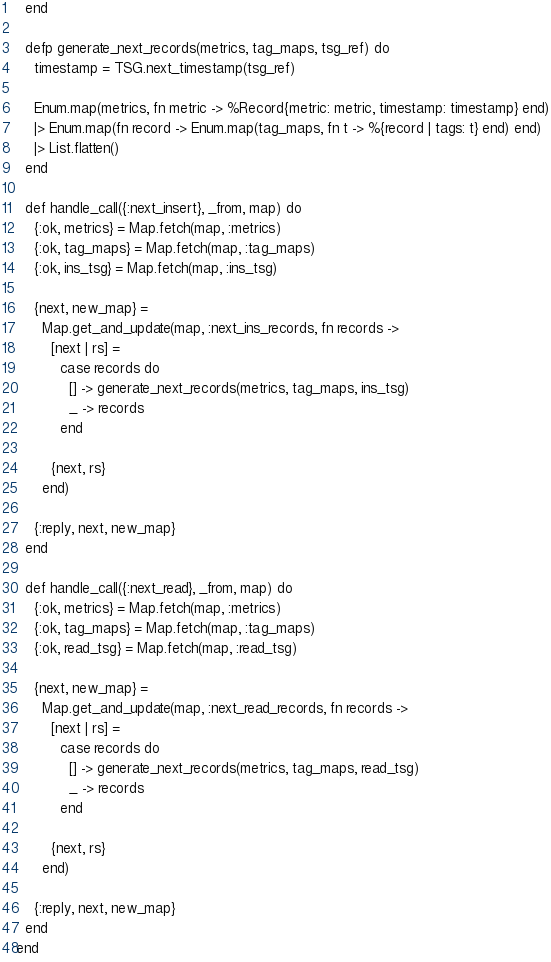<code> <loc_0><loc_0><loc_500><loc_500><_Elixir_>  end

  defp generate_next_records(metrics, tag_maps, tsg_ref) do
    timestamp = TSG.next_timestamp(tsg_ref)

    Enum.map(metrics, fn metric -> %Record{metric: metric, timestamp: timestamp} end)
    |> Enum.map(fn record -> Enum.map(tag_maps, fn t -> %{record | tags: t} end) end)
    |> List.flatten()
  end

  def handle_call({:next_insert}, _from, map) do
    {:ok, metrics} = Map.fetch(map, :metrics)
    {:ok, tag_maps} = Map.fetch(map, :tag_maps)
    {:ok, ins_tsg} = Map.fetch(map, :ins_tsg)

    {next, new_map} =
      Map.get_and_update(map, :next_ins_records, fn records ->
        [next | rs] =
          case records do
            [] -> generate_next_records(metrics, tag_maps, ins_tsg)
            _ -> records
          end

        {next, rs}
      end)

    {:reply, next, new_map}
  end

  def handle_call({:next_read}, _from, map) do
    {:ok, metrics} = Map.fetch(map, :metrics)
    {:ok, tag_maps} = Map.fetch(map, :tag_maps)
    {:ok, read_tsg} = Map.fetch(map, :read_tsg)

    {next, new_map} =
      Map.get_and_update(map, :next_read_records, fn records ->
        [next | rs] =
          case records do
            [] -> generate_next_records(metrics, tag_maps, read_tsg)
            _ -> records
          end

        {next, rs}
      end)

    {:reply, next, new_map}
  end
end
</code> 